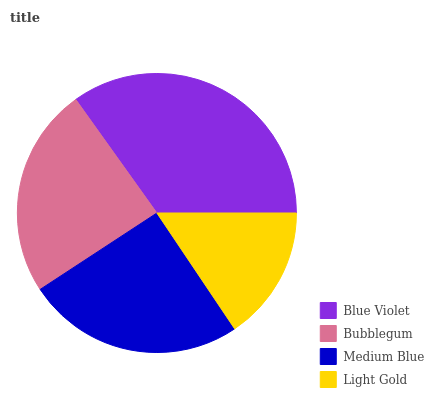Is Light Gold the minimum?
Answer yes or no. Yes. Is Blue Violet the maximum?
Answer yes or no. Yes. Is Bubblegum the minimum?
Answer yes or no. No. Is Bubblegum the maximum?
Answer yes or no. No. Is Blue Violet greater than Bubblegum?
Answer yes or no. Yes. Is Bubblegum less than Blue Violet?
Answer yes or no. Yes. Is Bubblegum greater than Blue Violet?
Answer yes or no. No. Is Blue Violet less than Bubblegum?
Answer yes or no. No. Is Medium Blue the high median?
Answer yes or no. Yes. Is Bubblegum the low median?
Answer yes or no. Yes. Is Light Gold the high median?
Answer yes or no. No. Is Blue Violet the low median?
Answer yes or no. No. 